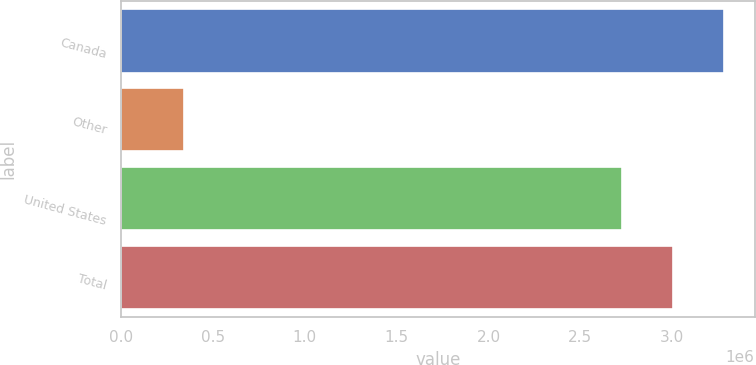Convert chart. <chart><loc_0><loc_0><loc_500><loc_500><bar_chart><fcel>Canada<fcel>Other<fcel>United States<fcel>Total<nl><fcel>3.28423e+06<fcel>339856<fcel>2.7252e+06<fcel>3.00471e+06<nl></chart> 